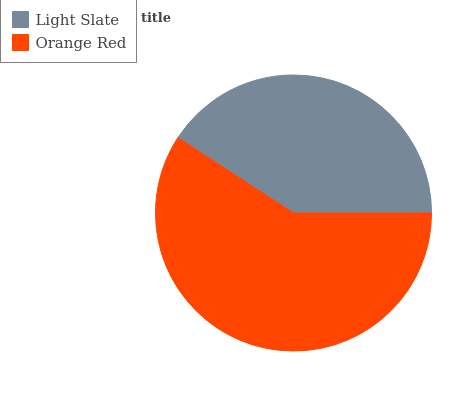Is Light Slate the minimum?
Answer yes or no. Yes. Is Orange Red the maximum?
Answer yes or no. Yes. Is Orange Red the minimum?
Answer yes or no. No. Is Orange Red greater than Light Slate?
Answer yes or no. Yes. Is Light Slate less than Orange Red?
Answer yes or no. Yes. Is Light Slate greater than Orange Red?
Answer yes or no. No. Is Orange Red less than Light Slate?
Answer yes or no. No. Is Orange Red the high median?
Answer yes or no. Yes. Is Light Slate the low median?
Answer yes or no. Yes. Is Light Slate the high median?
Answer yes or no. No. Is Orange Red the low median?
Answer yes or no. No. 